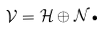Convert formula to latex. <formula><loc_0><loc_0><loc_500><loc_500>\mathcal { V } = \mathcal { H } \oplus \mathcal { N } \text {.}</formula> 